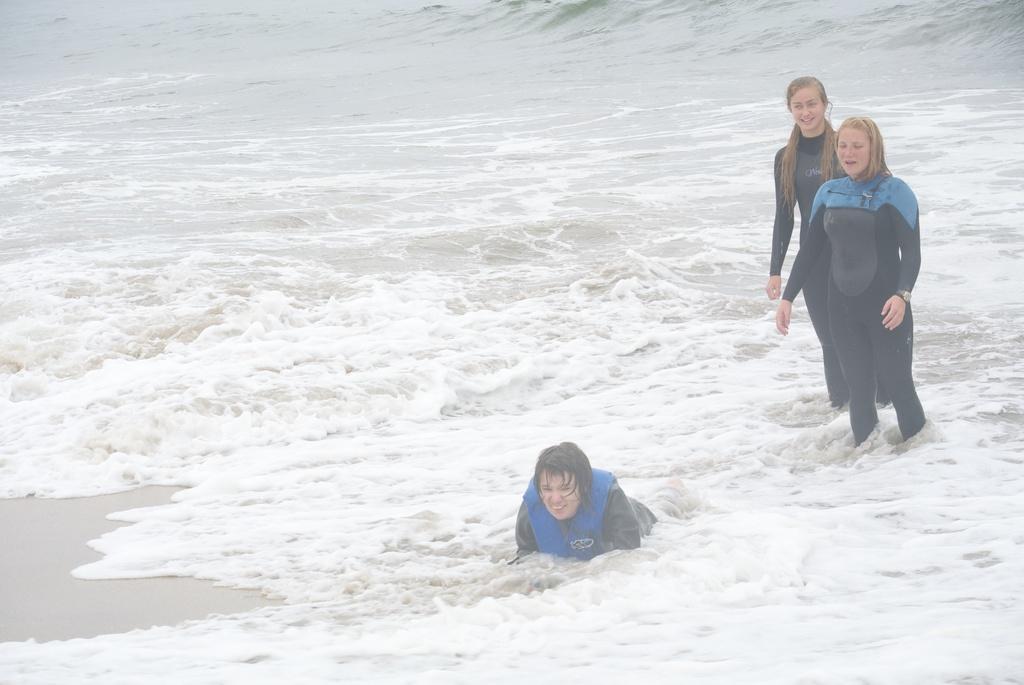Describe this image in one or two sentences. In this image we can see three women. In the background we can see the water. 